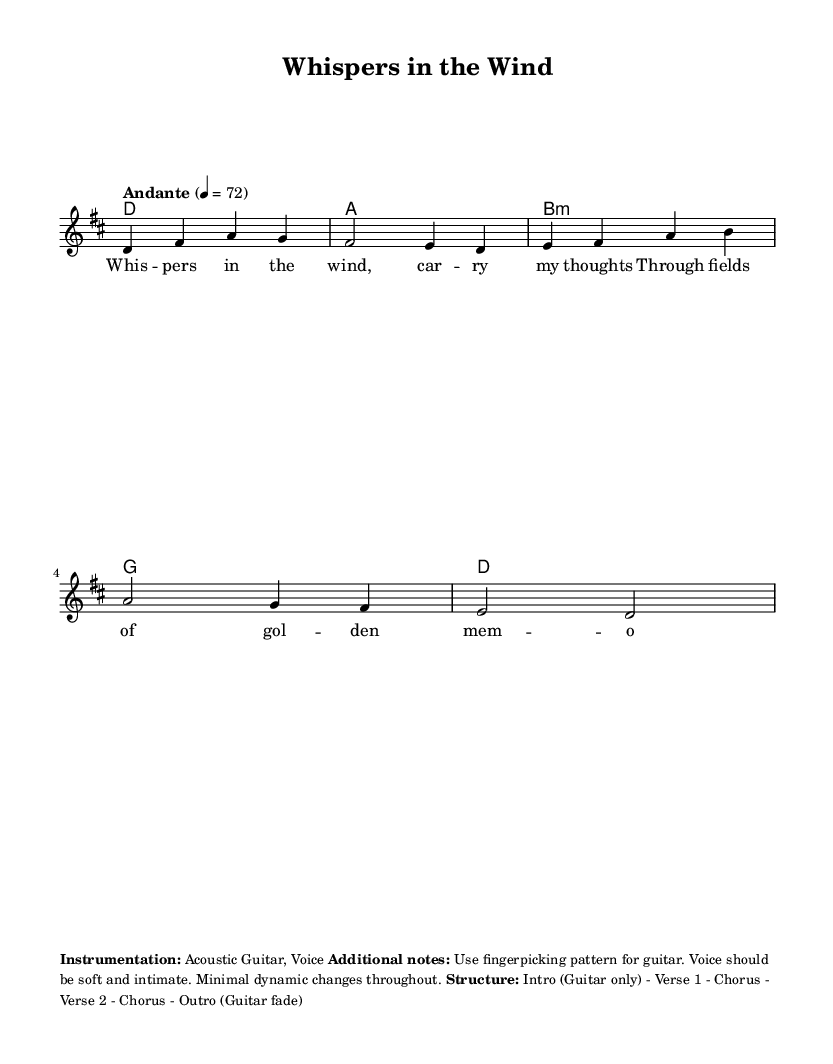What is the key signature of this music? The key signature is indicated at the beginning of the score and features two sharps, which correspond to D major.
Answer: D major What is the time signature of this piece? The time signature is shown at the start of the sheet music and is 4/4, indicating four beats per measure.
Answer: 4/4 What is the tempo marking of this piece? The tempo marking is found above the staff, specifying "Andante" with a metronome marking of 72 beats per minute.
Answer: Andante, 72 How many measures are in the melody? By counting the grouped notes in the melody section, we see it consists of six measures.
Answer: Six What instrumentation is used for this piece? The instrumentation details are provided in the markup section of the music, which states it is for Acoustic Guitar and Voice.
Answer: Acoustic Guitar, Voice What type of musical structure is indicated for this song? The structure is outlined in the markup and indicates an Intro (Guitar only), followed by two verses and choruses, concluding with an Outro (Guitar fade).
Answer: Intro - Verse 1 - Chorus - Verse 2 - Chorus - Outro What lyrical theme can be inferred from the verses? Analyzing the lyrics reveals a sentiment of nostalgia and longing, evident in phrases like "carry my thoughts" and "fields of golden memories."
Answer: Nostalgia and longing 